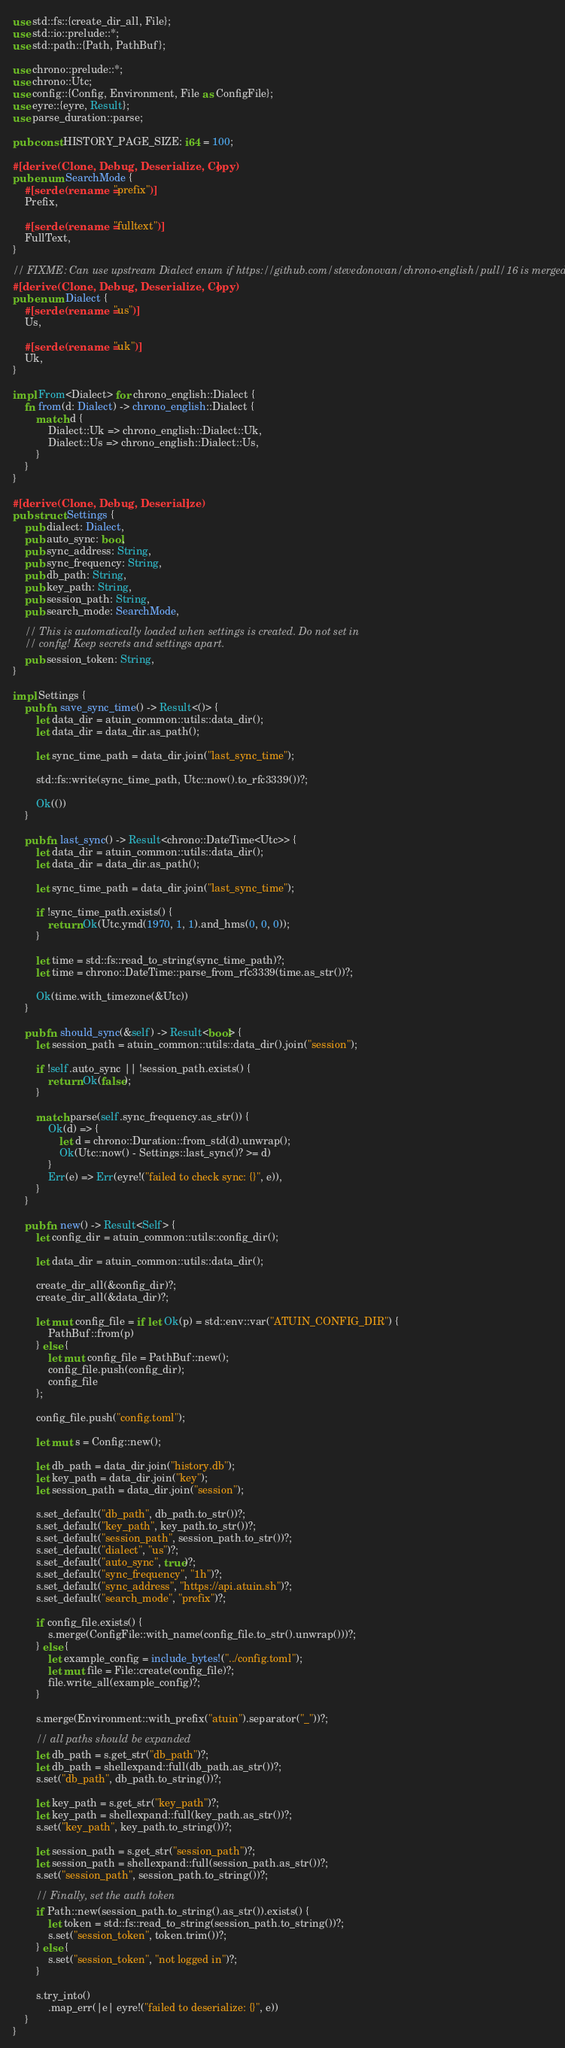Convert code to text. <code><loc_0><loc_0><loc_500><loc_500><_Rust_>use std::fs::{create_dir_all, File};
use std::io::prelude::*;
use std::path::{Path, PathBuf};

use chrono::prelude::*;
use chrono::Utc;
use config::{Config, Environment, File as ConfigFile};
use eyre::{eyre, Result};
use parse_duration::parse;

pub const HISTORY_PAGE_SIZE: i64 = 100;

#[derive(Clone, Debug, Deserialize, Copy)]
pub enum SearchMode {
    #[serde(rename = "prefix")]
    Prefix,

    #[serde(rename = "fulltext")]
    FullText,
}

// FIXME: Can use upstream Dialect enum if https://github.com/stevedonovan/chrono-english/pull/16 is merged
#[derive(Clone, Debug, Deserialize, Copy)]
pub enum Dialect {
    #[serde(rename = "us")]
    Us,

    #[serde(rename = "uk")]
    Uk,
}

impl From<Dialect> for chrono_english::Dialect {
    fn from(d: Dialect) -> chrono_english::Dialect {
        match d {
            Dialect::Uk => chrono_english::Dialect::Uk,
            Dialect::Us => chrono_english::Dialect::Us,
        }
    }
}

#[derive(Clone, Debug, Deserialize)]
pub struct Settings {
    pub dialect: Dialect,
    pub auto_sync: bool,
    pub sync_address: String,
    pub sync_frequency: String,
    pub db_path: String,
    pub key_path: String,
    pub session_path: String,
    pub search_mode: SearchMode,

    // This is automatically loaded when settings is created. Do not set in
    // config! Keep secrets and settings apart.
    pub session_token: String,
}

impl Settings {
    pub fn save_sync_time() -> Result<()> {
        let data_dir = atuin_common::utils::data_dir();
        let data_dir = data_dir.as_path();

        let sync_time_path = data_dir.join("last_sync_time");

        std::fs::write(sync_time_path, Utc::now().to_rfc3339())?;

        Ok(())
    }

    pub fn last_sync() -> Result<chrono::DateTime<Utc>> {
        let data_dir = atuin_common::utils::data_dir();
        let data_dir = data_dir.as_path();

        let sync_time_path = data_dir.join("last_sync_time");

        if !sync_time_path.exists() {
            return Ok(Utc.ymd(1970, 1, 1).and_hms(0, 0, 0));
        }

        let time = std::fs::read_to_string(sync_time_path)?;
        let time = chrono::DateTime::parse_from_rfc3339(time.as_str())?;

        Ok(time.with_timezone(&Utc))
    }

    pub fn should_sync(&self) -> Result<bool> {
        let session_path = atuin_common::utils::data_dir().join("session");

        if !self.auto_sync || !session_path.exists() {
            return Ok(false);
        }

        match parse(self.sync_frequency.as_str()) {
            Ok(d) => {
                let d = chrono::Duration::from_std(d).unwrap();
                Ok(Utc::now() - Settings::last_sync()? >= d)
            }
            Err(e) => Err(eyre!("failed to check sync: {}", e)),
        }
    }

    pub fn new() -> Result<Self> {
        let config_dir = atuin_common::utils::config_dir();

        let data_dir = atuin_common::utils::data_dir();

        create_dir_all(&config_dir)?;
        create_dir_all(&data_dir)?;

        let mut config_file = if let Ok(p) = std::env::var("ATUIN_CONFIG_DIR") {
            PathBuf::from(p)
        } else {
            let mut config_file = PathBuf::new();
            config_file.push(config_dir);
            config_file
        };

        config_file.push("config.toml");

        let mut s = Config::new();

        let db_path = data_dir.join("history.db");
        let key_path = data_dir.join("key");
        let session_path = data_dir.join("session");

        s.set_default("db_path", db_path.to_str())?;
        s.set_default("key_path", key_path.to_str())?;
        s.set_default("session_path", session_path.to_str())?;
        s.set_default("dialect", "us")?;
        s.set_default("auto_sync", true)?;
        s.set_default("sync_frequency", "1h")?;
        s.set_default("sync_address", "https://api.atuin.sh")?;
        s.set_default("search_mode", "prefix")?;

        if config_file.exists() {
            s.merge(ConfigFile::with_name(config_file.to_str().unwrap()))?;
        } else {
            let example_config = include_bytes!("../config.toml");
            let mut file = File::create(config_file)?;
            file.write_all(example_config)?;
        }

        s.merge(Environment::with_prefix("atuin").separator("_"))?;

        // all paths should be expanded
        let db_path = s.get_str("db_path")?;
        let db_path = shellexpand::full(db_path.as_str())?;
        s.set("db_path", db_path.to_string())?;

        let key_path = s.get_str("key_path")?;
        let key_path = shellexpand::full(key_path.as_str())?;
        s.set("key_path", key_path.to_string())?;

        let session_path = s.get_str("session_path")?;
        let session_path = shellexpand::full(session_path.as_str())?;
        s.set("session_path", session_path.to_string())?;

        // Finally, set the auth token
        if Path::new(session_path.to_string().as_str()).exists() {
            let token = std::fs::read_to_string(session_path.to_string())?;
            s.set("session_token", token.trim())?;
        } else {
            s.set("session_token", "not logged in")?;
        }

        s.try_into()
            .map_err(|e| eyre!("failed to deserialize: {}", e))
    }
}
</code> 